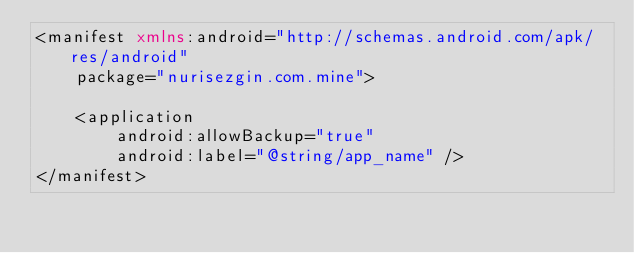<code> <loc_0><loc_0><loc_500><loc_500><_XML_><manifest xmlns:android="http://schemas.android.com/apk/res/android"
    package="nurisezgin.com.mine">

    <application
        android:allowBackup="true"
        android:label="@string/app_name" />
</manifest>
</code> 